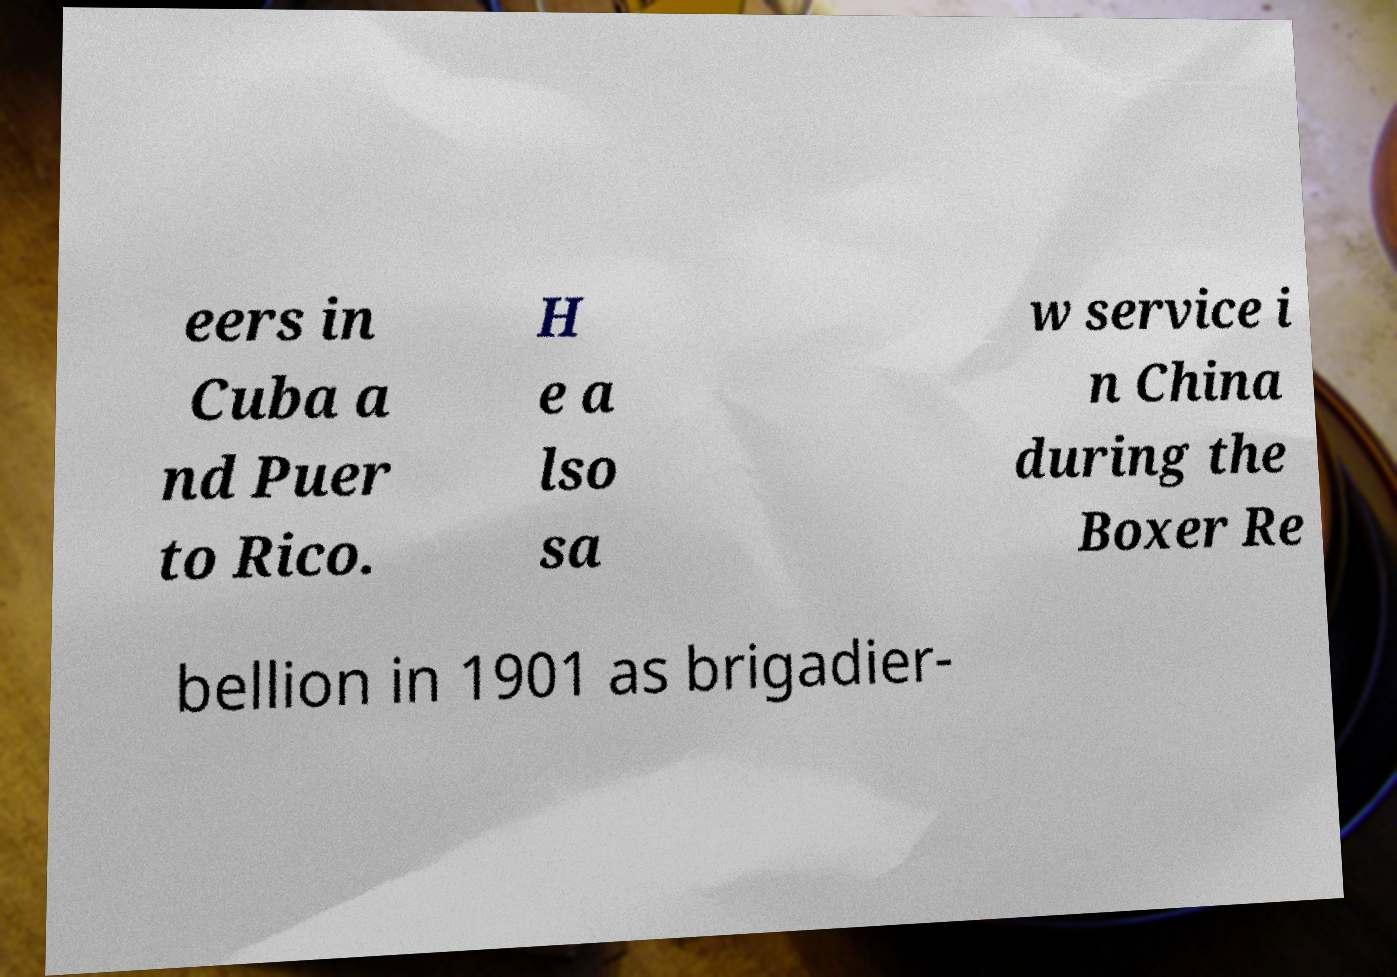What messages or text are displayed in this image? I need them in a readable, typed format. eers in Cuba a nd Puer to Rico. H e a lso sa w service i n China during the Boxer Re bellion in 1901 as brigadier- 